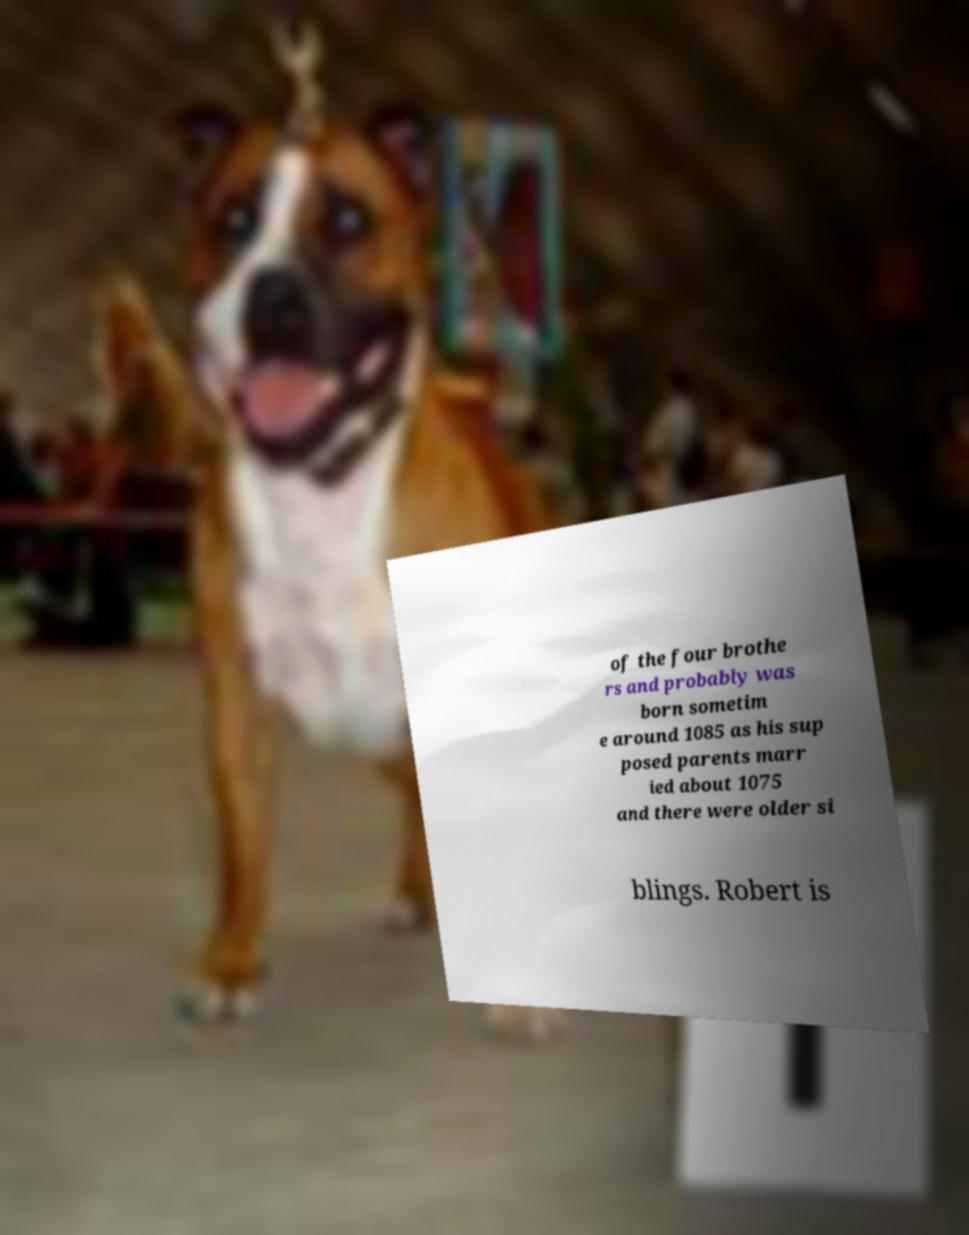There's text embedded in this image that I need extracted. Can you transcribe it verbatim? of the four brothe rs and probably was born sometim e around 1085 as his sup posed parents marr ied about 1075 and there were older si blings. Robert is 